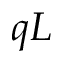Convert formula to latex. <formula><loc_0><loc_0><loc_500><loc_500>q L</formula> 